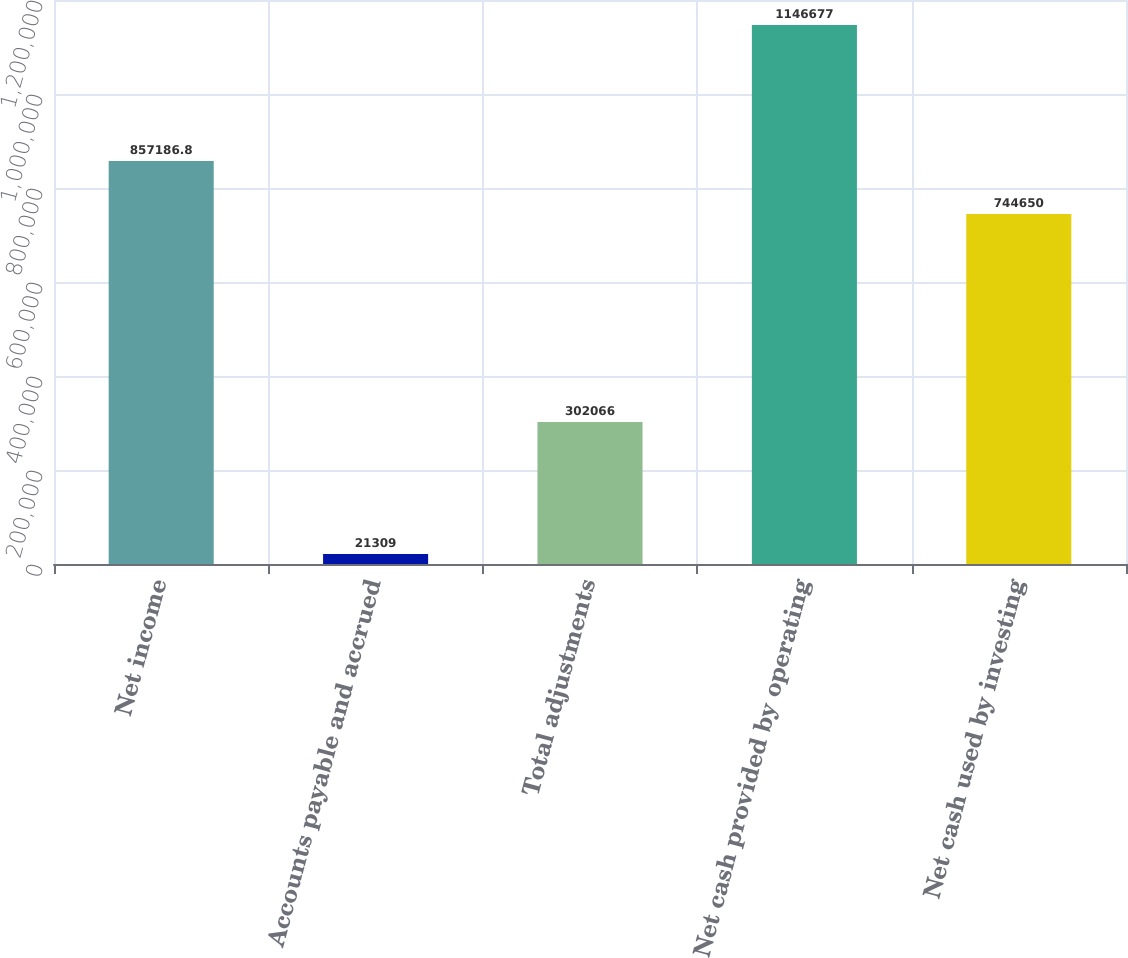<chart> <loc_0><loc_0><loc_500><loc_500><bar_chart><fcel>Net income<fcel>Accounts payable and accrued<fcel>Total adjustments<fcel>Net cash provided by operating<fcel>Net cash used by investing<nl><fcel>857187<fcel>21309<fcel>302066<fcel>1.14668e+06<fcel>744650<nl></chart> 